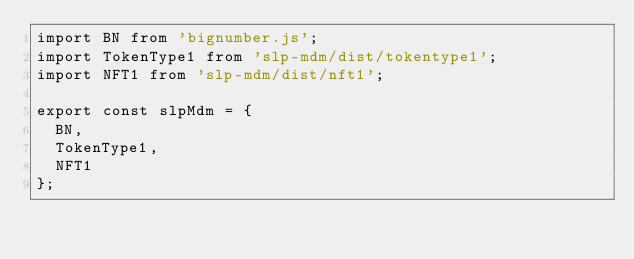<code> <loc_0><loc_0><loc_500><loc_500><_TypeScript_>import BN from 'bignumber.js';
import TokenType1 from 'slp-mdm/dist/tokentype1';
import NFT1 from 'slp-mdm/dist/nft1';

export const slpMdm = {
  BN,
  TokenType1,
  NFT1
};
</code> 